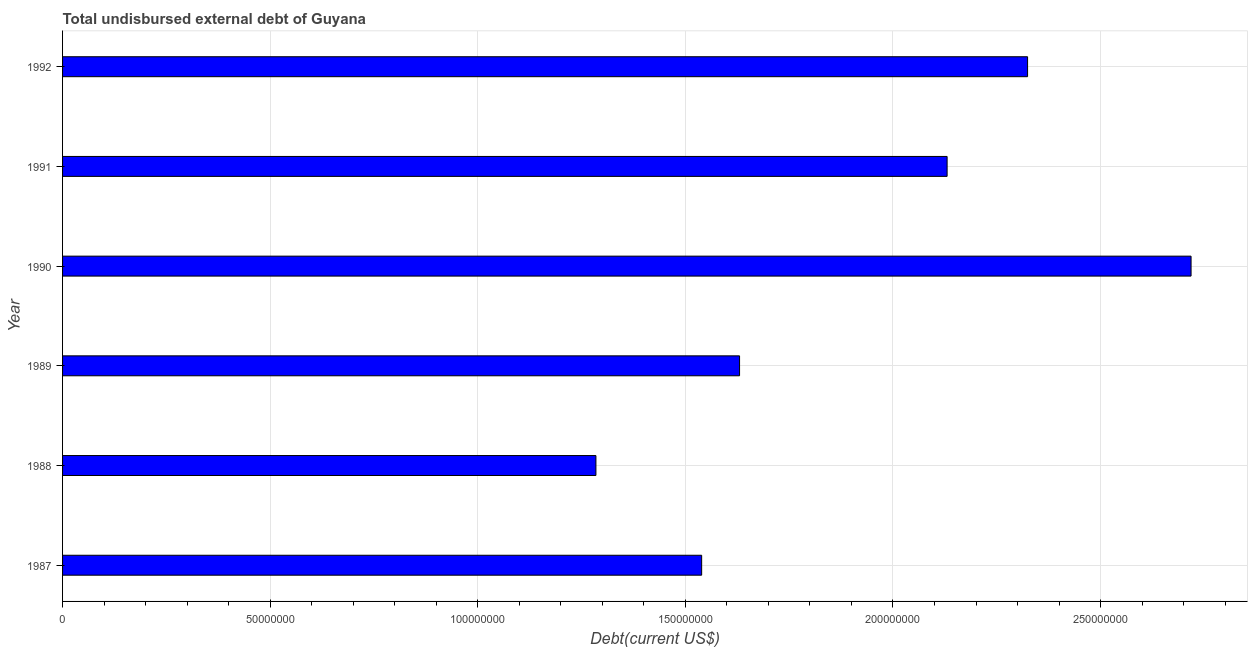Does the graph contain grids?
Keep it short and to the point. Yes. What is the title of the graph?
Offer a terse response. Total undisbursed external debt of Guyana. What is the label or title of the X-axis?
Provide a succinct answer. Debt(current US$). What is the total debt in 1988?
Your response must be concise. 1.28e+08. Across all years, what is the maximum total debt?
Make the answer very short. 2.72e+08. Across all years, what is the minimum total debt?
Your response must be concise. 1.28e+08. What is the sum of the total debt?
Your answer should be very brief. 1.16e+09. What is the difference between the total debt in 1989 and 1991?
Your answer should be compact. -5.00e+07. What is the average total debt per year?
Offer a very short reply. 1.94e+08. What is the median total debt?
Keep it short and to the point. 1.88e+08. In how many years, is the total debt greater than 150000000 US$?
Your answer should be very brief. 5. What is the ratio of the total debt in 1988 to that in 1992?
Make the answer very short. 0.55. Is the difference between the total debt in 1987 and 1989 greater than the difference between any two years?
Provide a succinct answer. No. What is the difference between the highest and the second highest total debt?
Your answer should be compact. 3.94e+07. What is the difference between the highest and the lowest total debt?
Offer a very short reply. 1.43e+08. How many bars are there?
Offer a terse response. 6. How many years are there in the graph?
Make the answer very short. 6. What is the difference between two consecutive major ticks on the X-axis?
Offer a very short reply. 5.00e+07. Are the values on the major ticks of X-axis written in scientific E-notation?
Give a very brief answer. No. What is the Debt(current US$) of 1987?
Your answer should be very brief. 1.54e+08. What is the Debt(current US$) of 1988?
Your answer should be compact. 1.28e+08. What is the Debt(current US$) in 1989?
Your answer should be very brief. 1.63e+08. What is the Debt(current US$) of 1990?
Offer a very short reply. 2.72e+08. What is the Debt(current US$) of 1991?
Ensure brevity in your answer.  2.13e+08. What is the Debt(current US$) in 1992?
Offer a very short reply. 2.32e+08. What is the difference between the Debt(current US$) in 1987 and 1988?
Your answer should be compact. 2.55e+07. What is the difference between the Debt(current US$) in 1987 and 1989?
Ensure brevity in your answer.  -9.13e+06. What is the difference between the Debt(current US$) in 1987 and 1990?
Provide a succinct answer. -1.18e+08. What is the difference between the Debt(current US$) in 1987 and 1991?
Provide a short and direct response. -5.91e+07. What is the difference between the Debt(current US$) in 1987 and 1992?
Offer a terse response. -7.85e+07. What is the difference between the Debt(current US$) in 1988 and 1989?
Provide a succinct answer. -3.46e+07. What is the difference between the Debt(current US$) in 1988 and 1990?
Keep it short and to the point. -1.43e+08. What is the difference between the Debt(current US$) in 1988 and 1991?
Offer a very short reply. -8.46e+07. What is the difference between the Debt(current US$) in 1988 and 1992?
Provide a succinct answer. -1.04e+08. What is the difference between the Debt(current US$) in 1989 and 1990?
Make the answer very short. -1.09e+08. What is the difference between the Debt(current US$) in 1989 and 1991?
Keep it short and to the point. -5.00e+07. What is the difference between the Debt(current US$) in 1989 and 1992?
Provide a succinct answer. -6.94e+07. What is the difference between the Debt(current US$) in 1990 and 1991?
Give a very brief answer. 5.88e+07. What is the difference between the Debt(current US$) in 1990 and 1992?
Provide a short and direct response. 3.94e+07. What is the difference between the Debt(current US$) in 1991 and 1992?
Offer a terse response. -1.94e+07. What is the ratio of the Debt(current US$) in 1987 to that in 1988?
Your answer should be compact. 1.2. What is the ratio of the Debt(current US$) in 1987 to that in 1989?
Give a very brief answer. 0.94. What is the ratio of the Debt(current US$) in 1987 to that in 1990?
Your answer should be compact. 0.57. What is the ratio of the Debt(current US$) in 1987 to that in 1991?
Ensure brevity in your answer.  0.72. What is the ratio of the Debt(current US$) in 1987 to that in 1992?
Offer a terse response. 0.66. What is the ratio of the Debt(current US$) in 1988 to that in 1989?
Provide a succinct answer. 0.79. What is the ratio of the Debt(current US$) in 1988 to that in 1990?
Your response must be concise. 0.47. What is the ratio of the Debt(current US$) in 1988 to that in 1991?
Provide a short and direct response. 0.6. What is the ratio of the Debt(current US$) in 1988 to that in 1992?
Make the answer very short. 0.55. What is the ratio of the Debt(current US$) in 1989 to that in 1991?
Your answer should be very brief. 0.77. What is the ratio of the Debt(current US$) in 1989 to that in 1992?
Offer a terse response. 0.7. What is the ratio of the Debt(current US$) in 1990 to that in 1991?
Your response must be concise. 1.28. What is the ratio of the Debt(current US$) in 1990 to that in 1992?
Provide a short and direct response. 1.17. What is the ratio of the Debt(current US$) in 1991 to that in 1992?
Offer a very short reply. 0.92. 